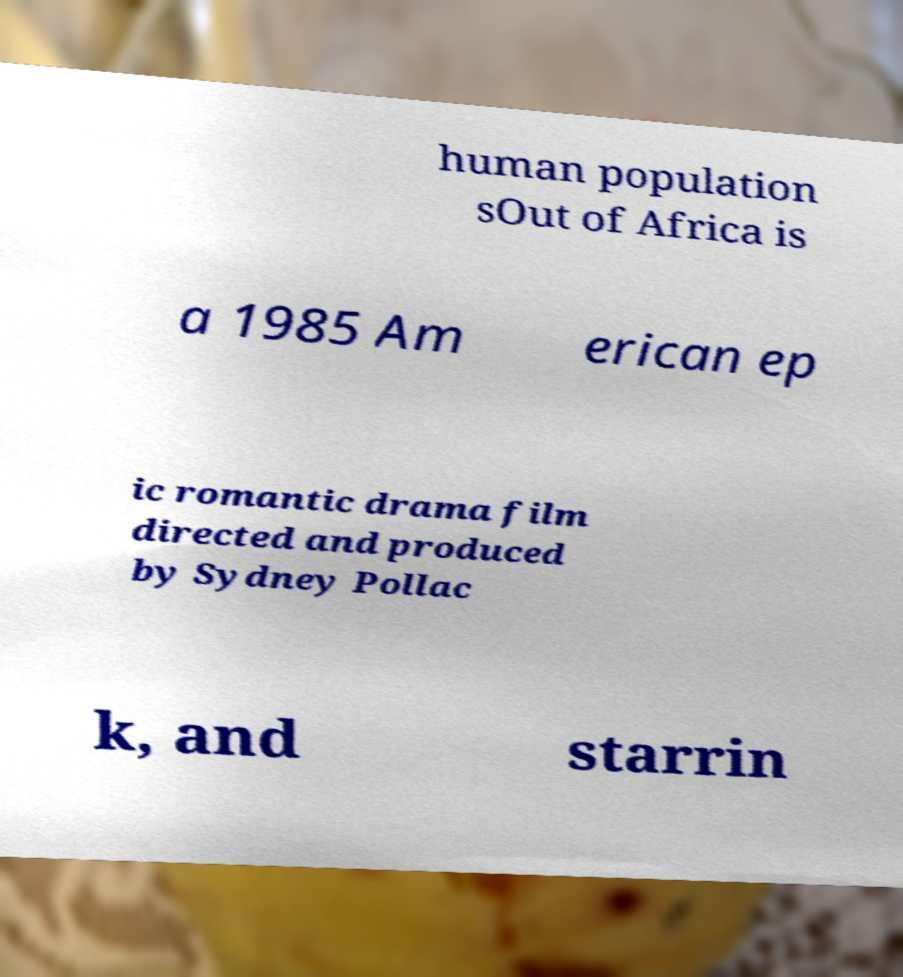Please read and relay the text visible in this image. What does it say? human population sOut of Africa is a 1985 Am erican ep ic romantic drama film directed and produced by Sydney Pollac k, and starrin 